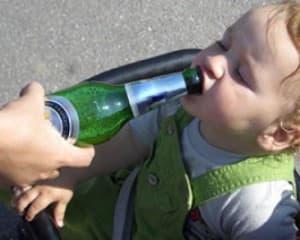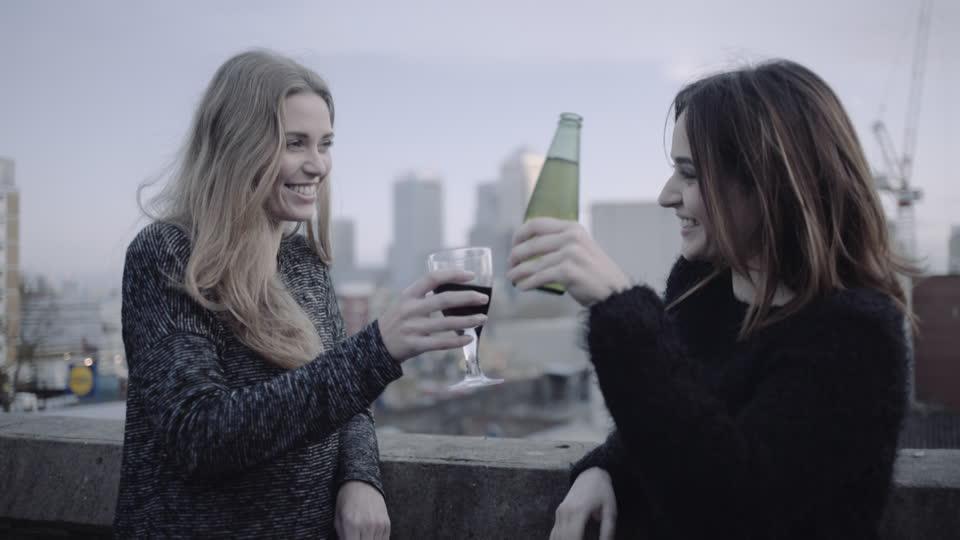The first image is the image on the left, the second image is the image on the right. Evaluate the accuracy of this statement regarding the images: "An adult is drinking a beer with the bottle touching their mouth.". Is it true? Answer yes or no. No. The first image is the image on the left, the second image is the image on the right. For the images shown, is this caption "Three hands are touching three bottles." true? Answer yes or no. No. 